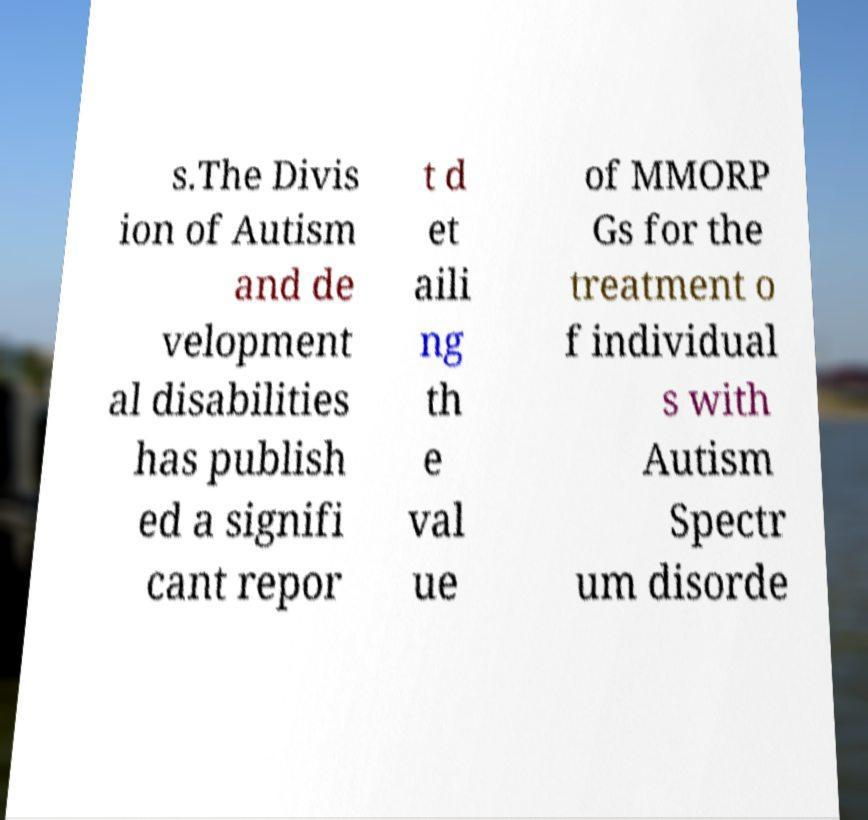Please identify and transcribe the text found in this image. s.The Divis ion of Autism and de velopment al disabilities has publish ed a signifi cant repor t d et aili ng th e val ue of MMORP Gs for the treatment o f individual s with Autism Spectr um disorde 